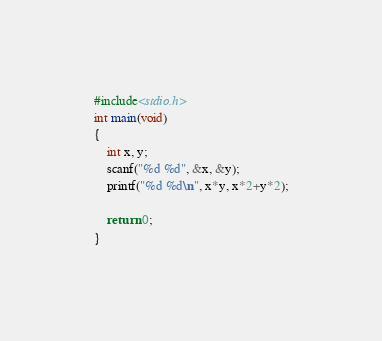<code> <loc_0><loc_0><loc_500><loc_500><_C_>#include<stdio.h>
int main(void)
{
	int x, y;
	scanf("%d %d", &x, &y);
	printf("%d %d\n", x*y, x*2+y*2);
	
	return 0;
}</code> 